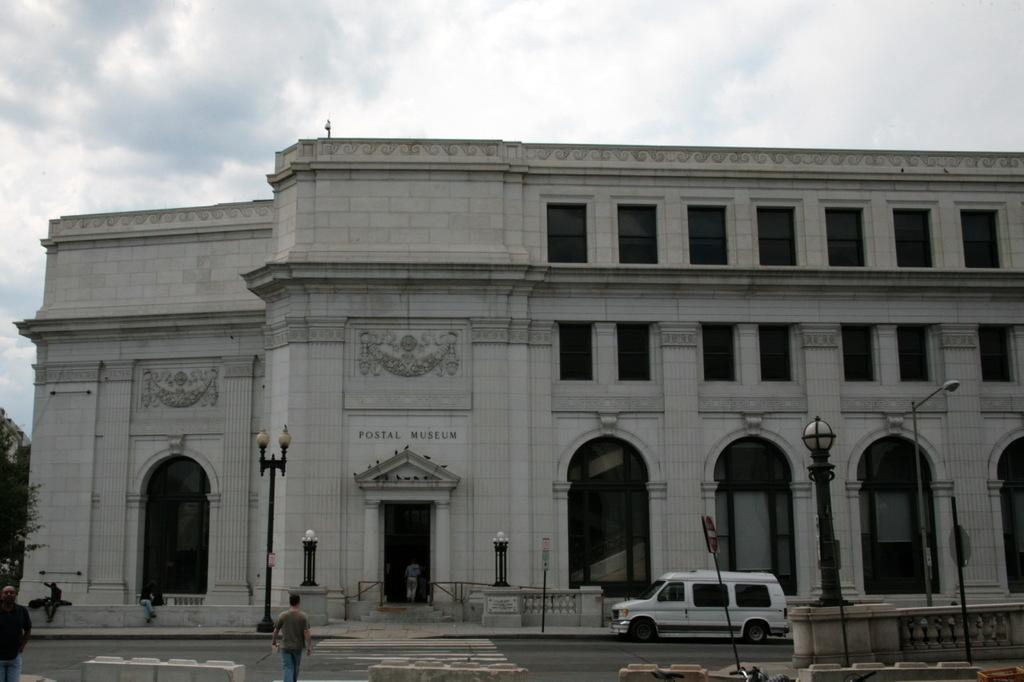<image>
Relay a brief, clear account of the picture shown. A white van is parked in front of the postal museum. 